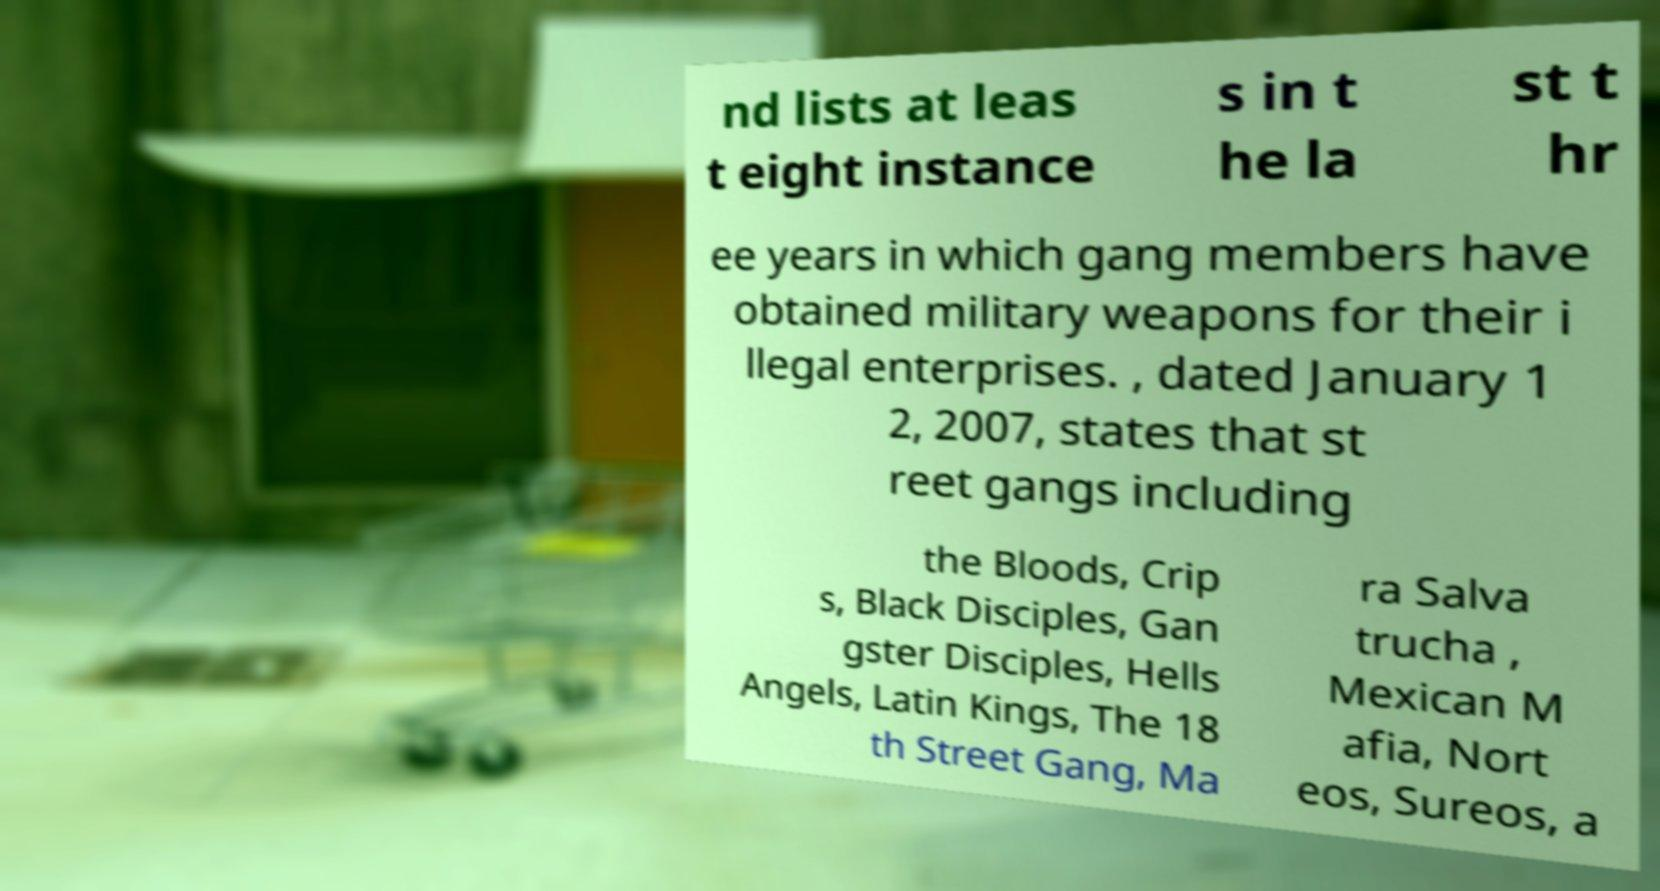I need the written content from this picture converted into text. Can you do that? nd lists at leas t eight instance s in t he la st t hr ee years in which gang members have obtained military weapons for their i llegal enterprises. , dated January 1 2, 2007, states that st reet gangs including the Bloods, Crip s, Black Disciples, Gan gster Disciples, Hells Angels, Latin Kings, The 18 th Street Gang, Ma ra Salva trucha , Mexican M afia, Nort eos, Sureos, a 